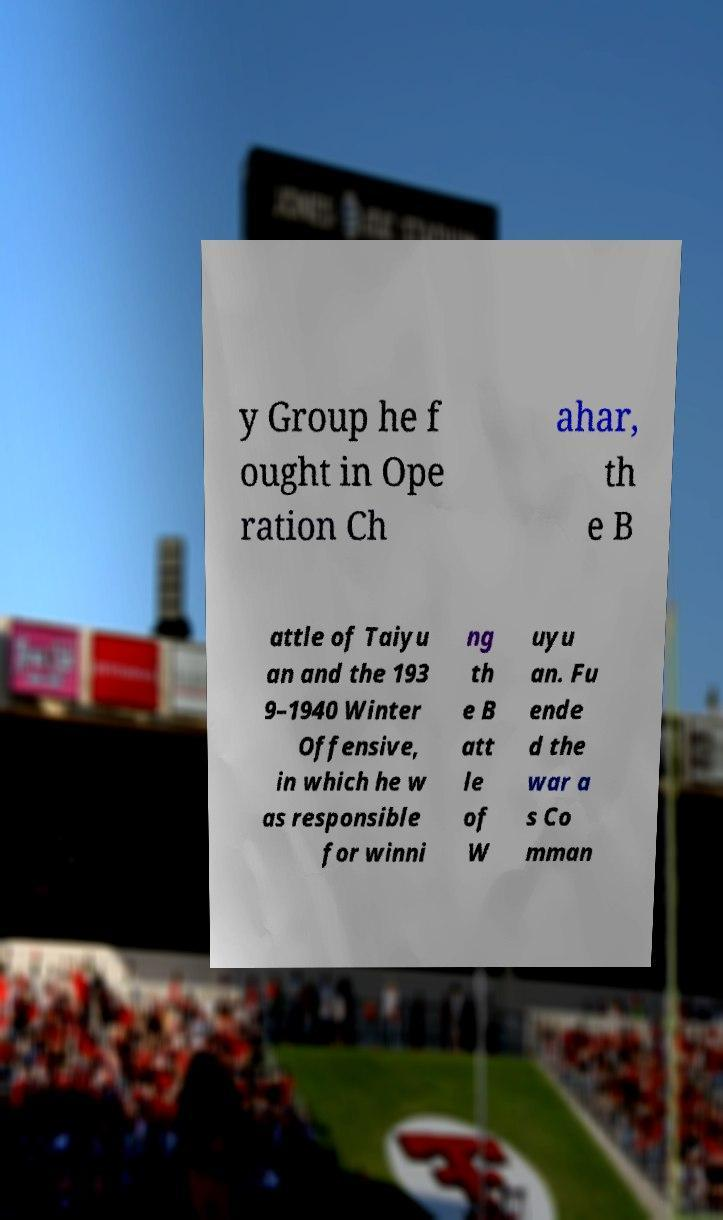For documentation purposes, I need the text within this image transcribed. Could you provide that? y Group he f ought in Ope ration Ch ahar, th e B attle of Taiyu an and the 193 9–1940 Winter Offensive, in which he w as responsible for winni ng th e B att le of W uyu an. Fu ende d the war a s Co mman 